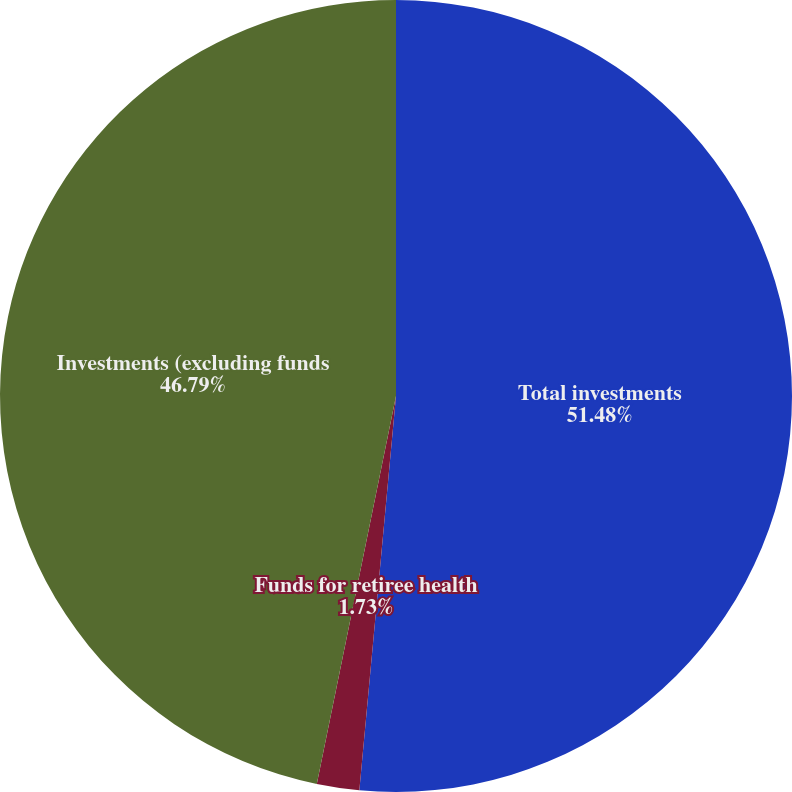Convert chart. <chart><loc_0><loc_0><loc_500><loc_500><pie_chart><fcel>Total investments<fcel>Funds for retiree health<fcel>Investments (excluding funds<nl><fcel>51.47%<fcel>1.73%<fcel>46.79%<nl></chart> 